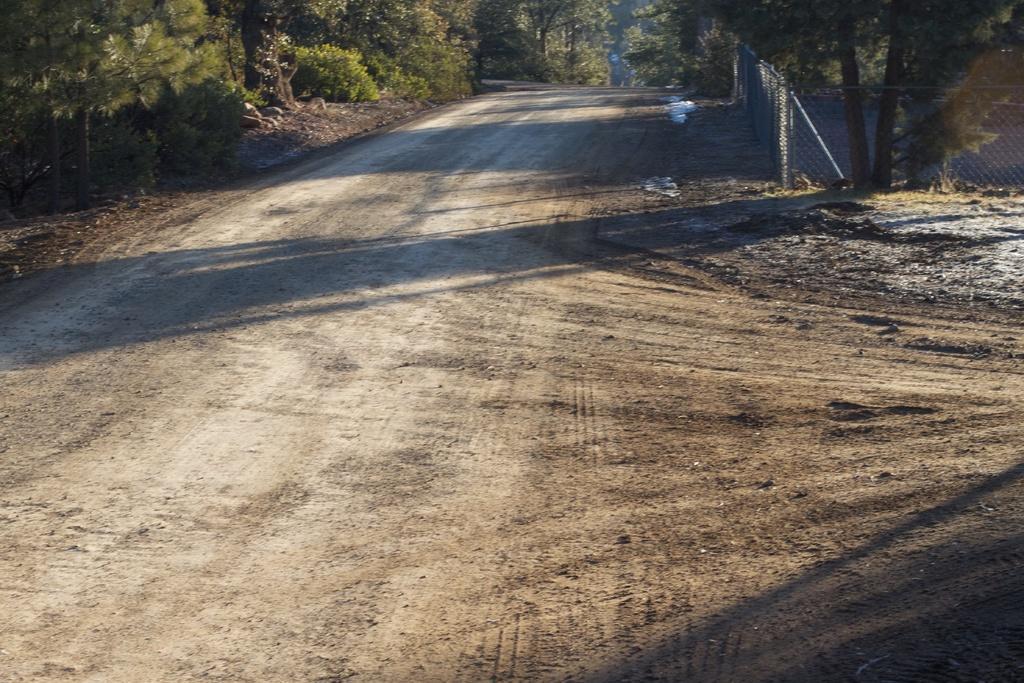Describe this image in one or two sentences. At the top of the image we can see trees, mesh are there. In the background of the image there is a ground. 